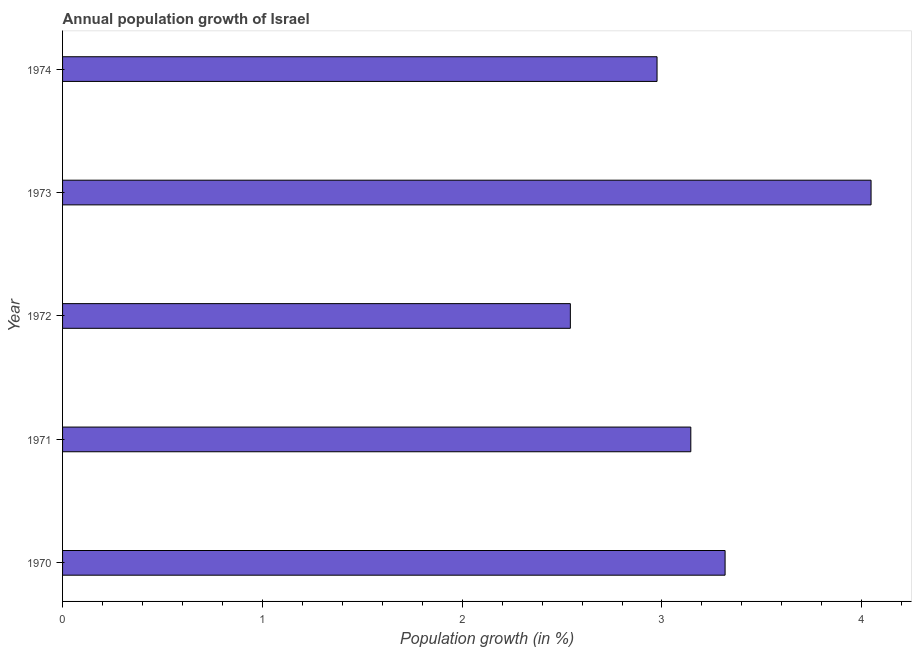Does the graph contain any zero values?
Ensure brevity in your answer.  No. Does the graph contain grids?
Give a very brief answer. No. What is the title of the graph?
Give a very brief answer. Annual population growth of Israel. What is the label or title of the X-axis?
Offer a terse response. Population growth (in %). What is the label or title of the Y-axis?
Ensure brevity in your answer.  Year. What is the population growth in 1970?
Your answer should be compact. 3.32. Across all years, what is the maximum population growth?
Give a very brief answer. 4.05. Across all years, what is the minimum population growth?
Your answer should be very brief. 2.54. In which year was the population growth maximum?
Your answer should be compact. 1973. In which year was the population growth minimum?
Make the answer very short. 1972. What is the sum of the population growth?
Make the answer very short. 16.02. What is the difference between the population growth in 1970 and 1971?
Ensure brevity in your answer.  0.17. What is the average population growth per year?
Ensure brevity in your answer.  3.21. What is the median population growth?
Provide a succinct answer. 3.14. Do a majority of the years between 1971 and 1970 (inclusive) have population growth greater than 0.2 %?
Ensure brevity in your answer.  No. What is the ratio of the population growth in 1970 to that in 1973?
Provide a succinct answer. 0.82. Is the difference between the population growth in 1971 and 1972 greater than the difference between any two years?
Your answer should be compact. No. What is the difference between the highest and the second highest population growth?
Provide a short and direct response. 0.73. What is the difference between the highest and the lowest population growth?
Offer a terse response. 1.51. In how many years, is the population growth greater than the average population growth taken over all years?
Your answer should be compact. 2. How many years are there in the graph?
Keep it short and to the point. 5. What is the difference between two consecutive major ticks on the X-axis?
Make the answer very short. 1. Are the values on the major ticks of X-axis written in scientific E-notation?
Give a very brief answer. No. What is the Population growth (in %) of 1970?
Provide a short and direct response. 3.32. What is the Population growth (in %) in 1971?
Give a very brief answer. 3.14. What is the Population growth (in %) in 1972?
Offer a terse response. 2.54. What is the Population growth (in %) of 1973?
Give a very brief answer. 4.05. What is the Population growth (in %) in 1974?
Your answer should be compact. 2.98. What is the difference between the Population growth (in %) in 1970 and 1971?
Offer a very short reply. 0.17. What is the difference between the Population growth (in %) in 1970 and 1972?
Offer a terse response. 0.77. What is the difference between the Population growth (in %) in 1970 and 1973?
Give a very brief answer. -0.73. What is the difference between the Population growth (in %) in 1970 and 1974?
Your answer should be compact. 0.34. What is the difference between the Population growth (in %) in 1971 and 1972?
Make the answer very short. 0.6. What is the difference between the Population growth (in %) in 1971 and 1973?
Your answer should be very brief. -0.9. What is the difference between the Population growth (in %) in 1971 and 1974?
Give a very brief answer. 0.17. What is the difference between the Population growth (in %) in 1972 and 1973?
Offer a very short reply. -1.51. What is the difference between the Population growth (in %) in 1972 and 1974?
Make the answer very short. -0.43. What is the difference between the Population growth (in %) in 1973 and 1974?
Provide a succinct answer. 1.07. What is the ratio of the Population growth (in %) in 1970 to that in 1971?
Provide a short and direct response. 1.05. What is the ratio of the Population growth (in %) in 1970 to that in 1972?
Keep it short and to the point. 1.3. What is the ratio of the Population growth (in %) in 1970 to that in 1973?
Give a very brief answer. 0.82. What is the ratio of the Population growth (in %) in 1970 to that in 1974?
Your response must be concise. 1.11. What is the ratio of the Population growth (in %) in 1971 to that in 1972?
Keep it short and to the point. 1.24. What is the ratio of the Population growth (in %) in 1971 to that in 1973?
Keep it short and to the point. 0.78. What is the ratio of the Population growth (in %) in 1971 to that in 1974?
Offer a very short reply. 1.06. What is the ratio of the Population growth (in %) in 1972 to that in 1973?
Offer a very short reply. 0.63. What is the ratio of the Population growth (in %) in 1972 to that in 1974?
Your answer should be very brief. 0.85. What is the ratio of the Population growth (in %) in 1973 to that in 1974?
Make the answer very short. 1.36. 